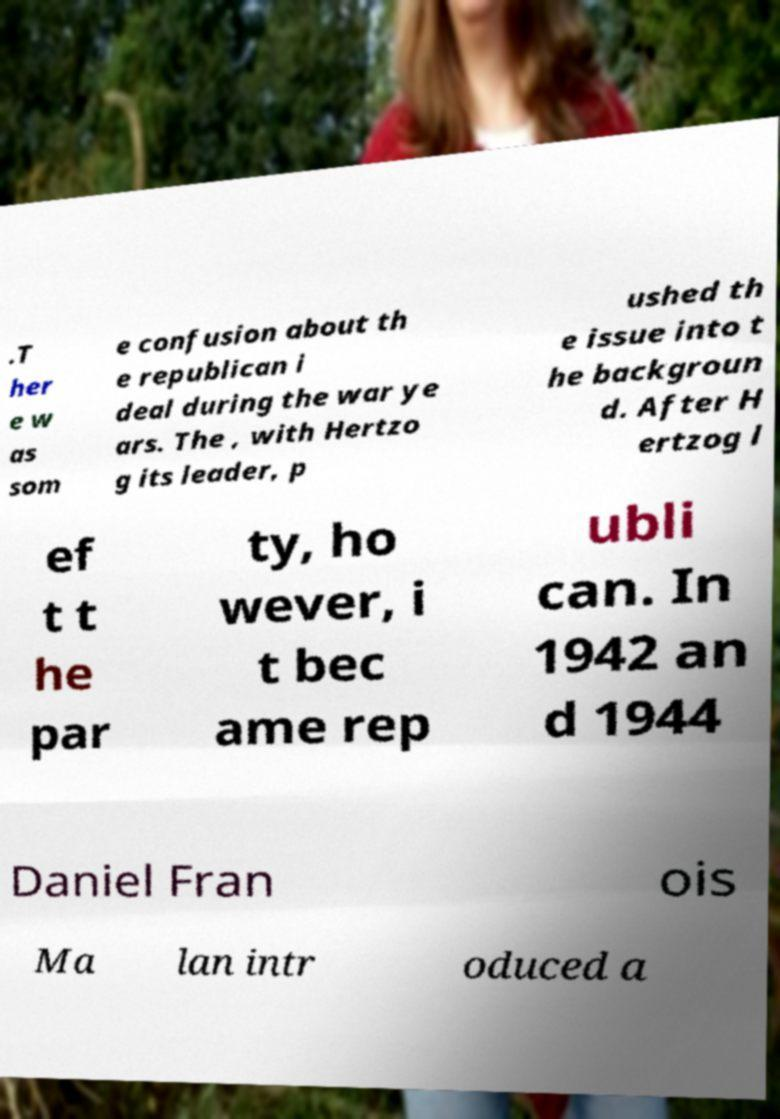Please read and relay the text visible in this image. What does it say? .T her e w as som e confusion about th e republican i deal during the war ye ars. The , with Hertzo g its leader, p ushed th e issue into t he backgroun d. After H ertzog l ef t t he par ty, ho wever, i t bec ame rep ubli can. In 1942 an d 1944 Daniel Fran ois Ma lan intr oduced a 